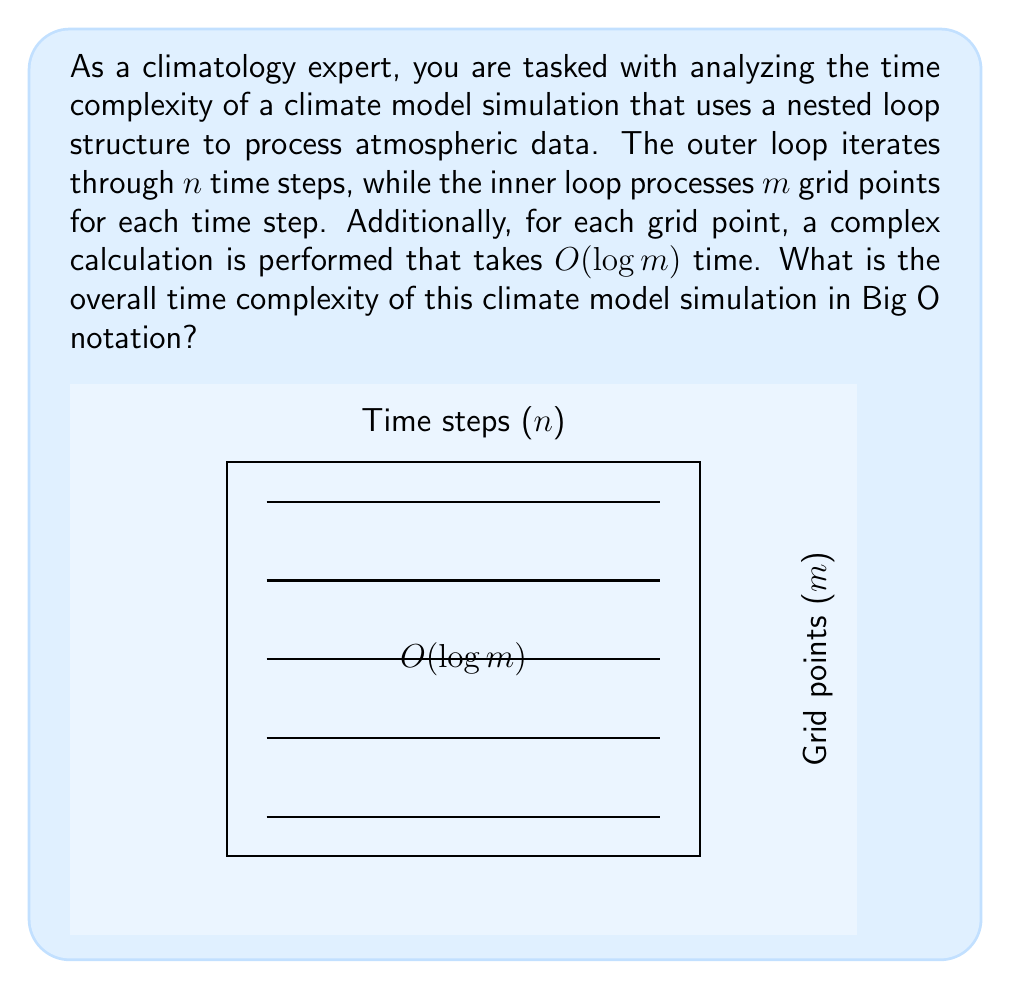Help me with this question. Let's analyze the time complexity step by step:

1) The outer loop iterates through $n$ time steps:
   $$T_{outer} = n$$

2) For each time step, the inner loop processes $m$ grid points:
   $$T_{inner} = m$$

3) For each grid point, a complex calculation is performed that takes $O(\log m)$ time:
   $$T_{calculation} = O(\log m)$$

4) The total operations for each iteration of the outer loop is:
   $$T_{per\_iteration} = m \cdot O(\log m) = O(m \log m)$$

5) Since the outer loop runs $n$ times, we multiply the operations per iteration by $n$:
   $$T_{total} = n \cdot O(m \log m) = O(n m \log m)$$

Therefore, the overall time complexity of the climate model simulation is $O(n m \log m)$.
Answer: $O(n m \log m)$ 